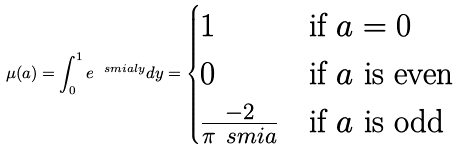Convert formula to latex. <formula><loc_0><loc_0><loc_500><loc_500>\mu ( a ) = \int _ { 0 } ^ { 1 } e ^ { \ s m i a l y } d y = \begin{cases} 1 & \text {if $a=0$} \\ 0 & \text {if $a$ is even} \\ \frac { - 2 } { \pi \ s m i a } & \text {if $a$ is odd} \end{cases}</formula> 